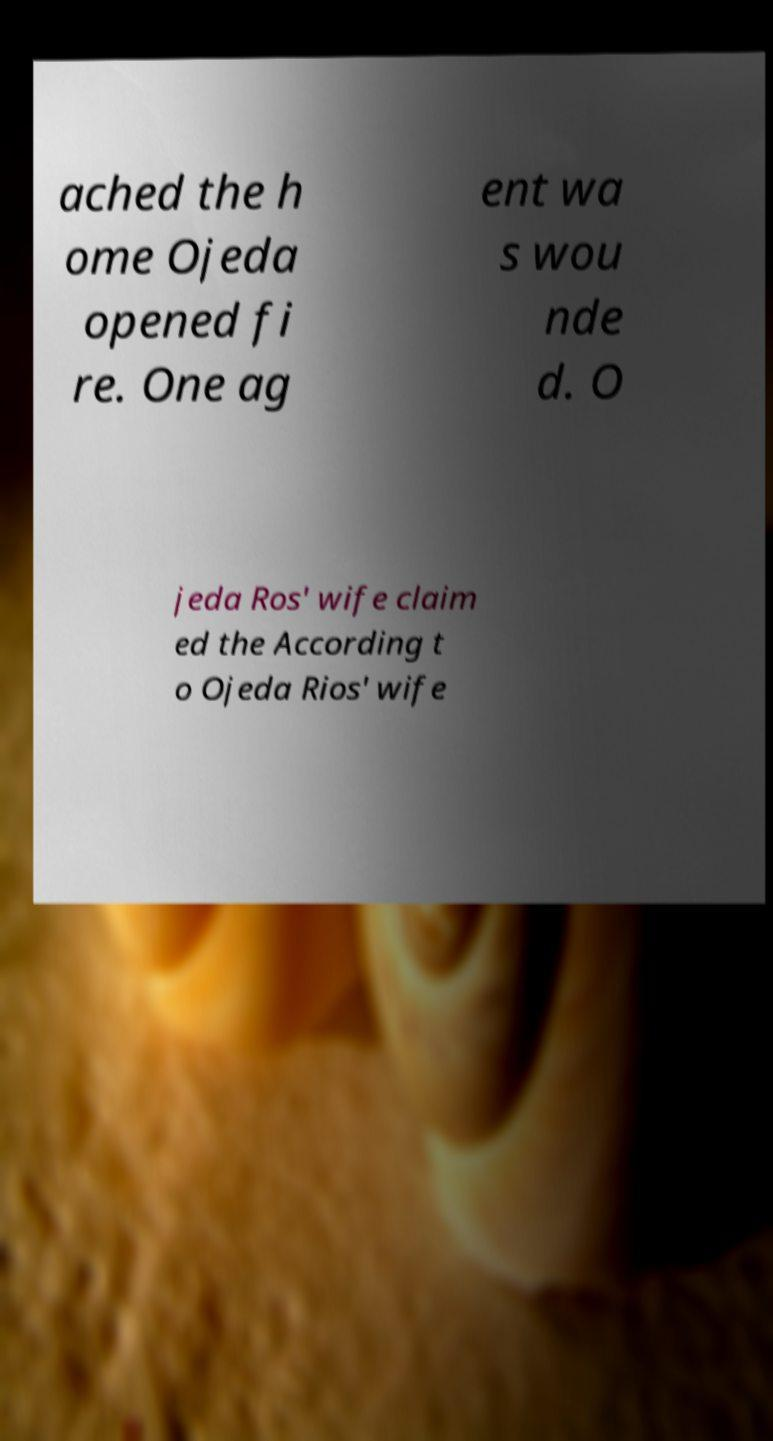I need the written content from this picture converted into text. Can you do that? ached the h ome Ojeda opened fi re. One ag ent wa s wou nde d. O jeda Ros' wife claim ed the According t o Ojeda Rios' wife 